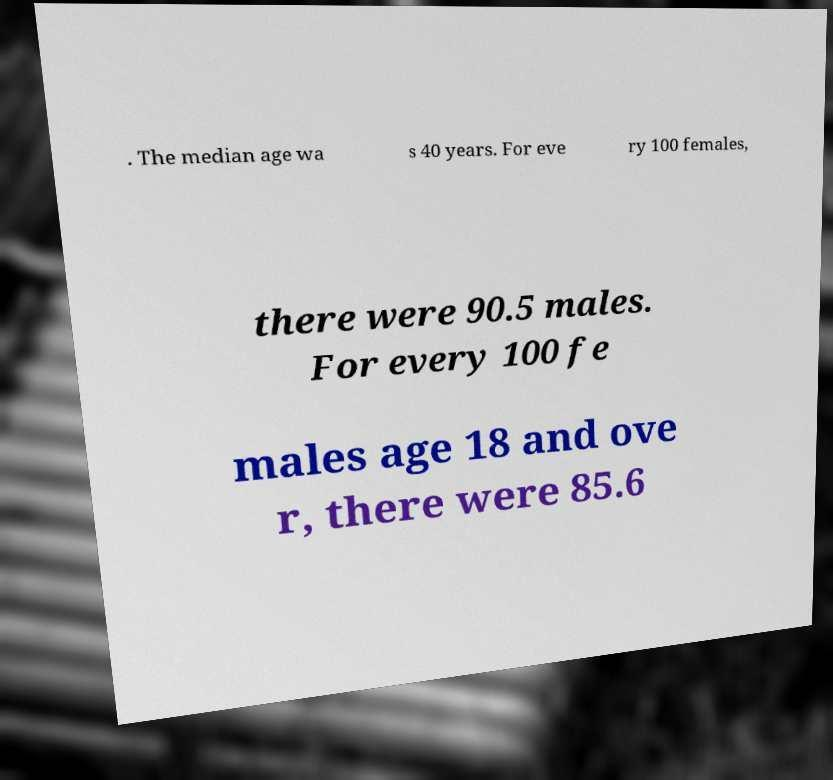What messages or text are displayed in this image? I need them in a readable, typed format. . The median age wa s 40 years. For eve ry 100 females, there were 90.5 males. For every 100 fe males age 18 and ove r, there were 85.6 